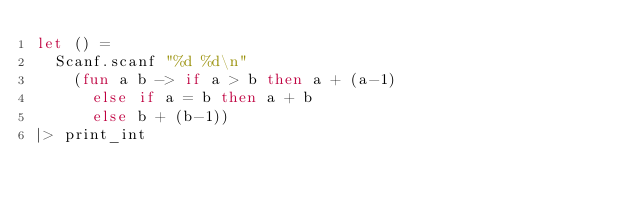<code> <loc_0><loc_0><loc_500><loc_500><_OCaml_>let () =
  Scanf.scanf "%d %d\n"
    (fun a b -> if a > b then a + (a-1)
      else if a = b then a + b
      else b + (b-1))
|> print_int
</code> 